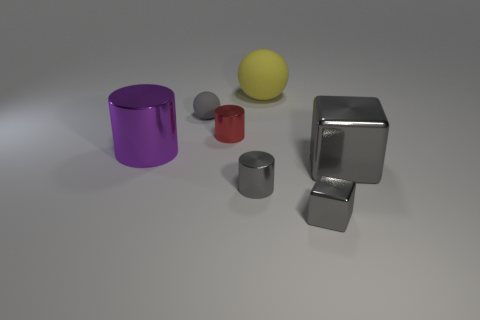Subtract all large purple metallic cylinders. How many cylinders are left? 2 Subtract 1 cylinders. How many cylinders are left? 2 Subtract all brown cylinders. Subtract all purple spheres. How many cylinders are left? 3 Add 1 yellow rubber spheres. How many objects exist? 8 Subtract all cubes. How many objects are left? 5 Add 6 small gray metal objects. How many small gray metal objects exist? 8 Subtract 0 green cubes. How many objects are left? 7 Subtract all tiny rubber blocks. Subtract all gray rubber things. How many objects are left? 6 Add 1 tiny matte things. How many tiny matte things are left? 2 